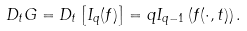Convert formula to latex. <formula><loc_0><loc_0><loc_500><loc_500>D _ { t } G = D _ { t } \left [ I _ { q } ( f ) \right ] = q I _ { q - 1 } \left ( f ( \cdot , t ) \right ) .</formula> 